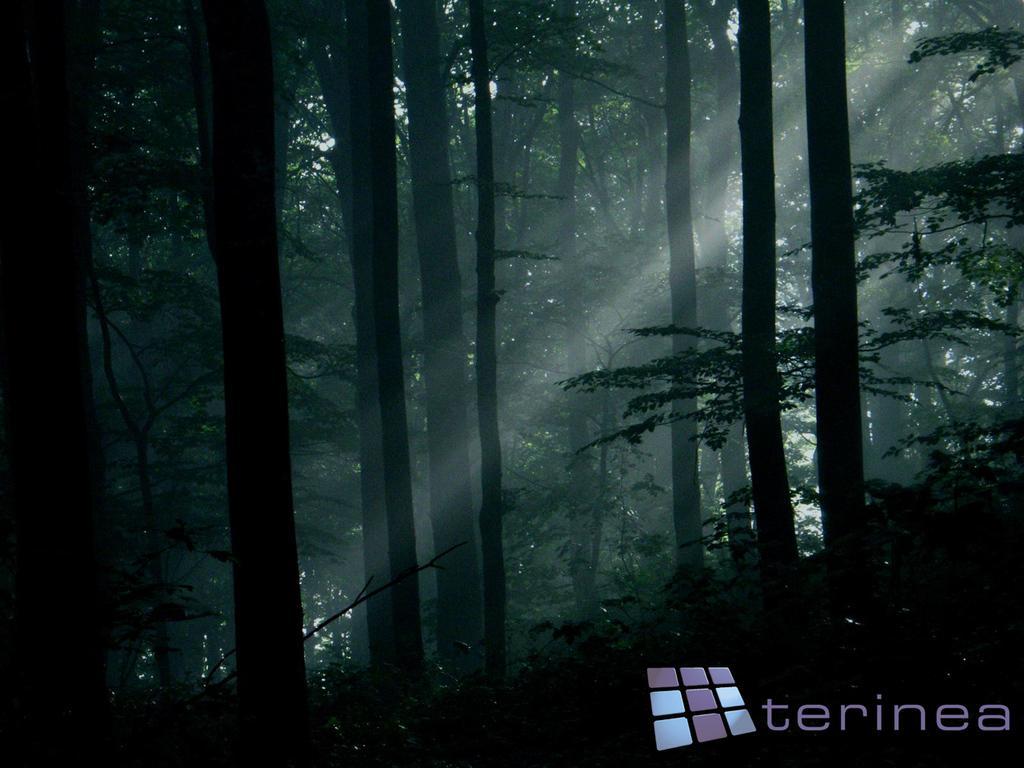Can you describe this image briefly? In this picture there are trees in the image. 